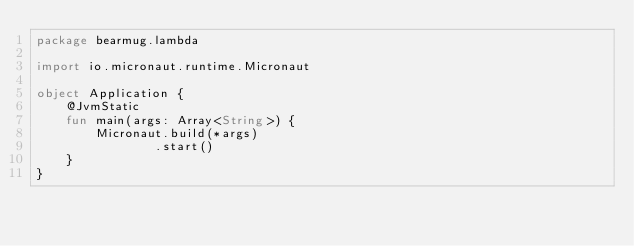<code> <loc_0><loc_0><loc_500><loc_500><_Kotlin_>package bearmug.lambda

import io.micronaut.runtime.Micronaut

object Application {
    @JvmStatic
    fun main(args: Array<String>) {
        Micronaut.build(*args)
                .start()
    }
}</code> 